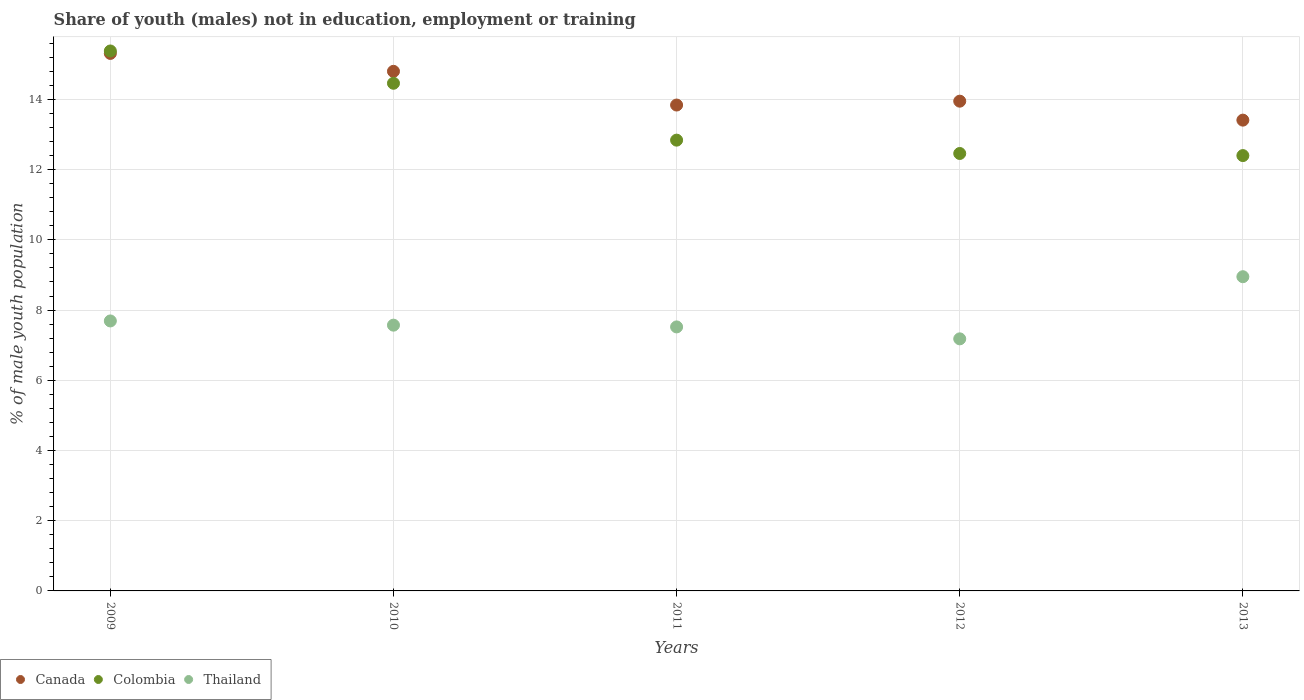What is the percentage of unemployed males population in in Colombia in 2012?
Provide a succinct answer. 12.46. Across all years, what is the maximum percentage of unemployed males population in in Canada?
Offer a very short reply. 15.31. Across all years, what is the minimum percentage of unemployed males population in in Colombia?
Keep it short and to the point. 12.4. In which year was the percentage of unemployed males population in in Canada minimum?
Your answer should be very brief. 2013. What is the total percentage of unemployed males population in in Canada in the graph?
Provide a short and direct response. 71.31. What is the difference between the percentage of unemployed males population in in Colombia in 2009 and that in 2012?
Make the answer very short. 2.92. What is the difference between the percentage of unemployed males population in in Colombia in 2010 and the percentage of unemployed males population in in Thailand in 2012?
Make the answer very short. 7.28. What is the average percentage of unemployed males population in in Canada per year?
Provide a short and direct response. 14.26. In the year 2011, what is the difference between the percentage of unemployed males population in in Thailand and percentage of unemployed males population in in Colombia?
Make the answer very short. -5.32. In how many years, is the percentage of unemployed males population in in Colombia greater than 12.8 %?
Offer a terse response. 3. What is the ratio of the percentage of unemployed males population in in Thailand in 2010 to that in 2011?
Give a very brief answer. 1.01. Is the difference between the percentage of unemployed males population in in Thailand in 2009 and 2012 greater than the difference between the percentage of unemployed males population in in Colombia in 2009 and 2012?
Offer a very short reply. No. What is the difference between the highest and the second highest percentage of unemployed males population in in Colombia?
Provide a short and direct response. 0.92. What is the difference between the highest and the lowest percentage of unemployed males population in in Colombia?
Ensure brevity in your answer.  2.98. Is it the case that in every year, the sum of the percentage of unemployed males population in in Canada and percentage of unemployed males population in in Colombia  is greater than the percentage of unemployed males population in in Thailand?
Your answer should be compact. Yes. Does the percentage of unemployed males population in in Colombia monotonically increase over the years?
Ensure brevity in your answer.  No. Is the percentage of unemployed males population in in Colombia strictly greater than the percentage of unemployed males population in in Thailand over the years?
Provide a short and direct response. Yes. Is the percentage of unemployed males population in in Canada strictly less than the percentage of unemployed males population in in Thailand over the years?
Keep it short and to the point. No. How many dotlines are there?
Your answer should be very brief. 3. How many years are there in the graph?
Your response must be concise. 5. What is the title of the graph?
Your answer should be very brief. Share of youth (males) not in education, employment or training. Does "Zimbabwe" appear as one of the legend labels in the graph?
Keep it short and to the point. No. What is the label or title of the Y-axis?
Ensure brevity in your answer.  % of male youth population. What is the % of male youth population in Canada in 2009?
Provide a short and direct response. 15.31. What is the % of male youth population of Colombia in 2009?
Provide a succinct answer. 15.38. What is the % of male youth population of Thailand in 2009?
Provide a short and direct response. 7.69. What is the % of male youth population in Canada in 2010?
Your response must be concise. 14.8. What is the % of male youth population of Colombia in 2010?
Offer a terse response. 14.46. What is the % of male youth population of Thailand in 2010?
Offer a very short reply. 7.57. What is the % of male youth population of Canada in 2011?
Provide a short and direct response. 13.84. What is the % of male youth population in Colombia in 2011?
Offer a terse response. 12.84. What is the % of male youth population of Thailand in 2011?
Provide a succinct answer. 7.52. What is the % of male youth population in Canada in 2012?
Make the answer very short. 13.95. What is the % of male youth population of Colombia in 2012?
Ensure brevity in your answer.  12.46. What is the % of male youth population of Thailand in 2012?
Make the answer very short. 7.18. What is the % of male youth population in Canada in 2013?
Give a very brief answer. 13.41. What is the % of male youth population in Colombia in 2013?
Offer a very short reply. 12.4. What is the % of male youth population in Thailand in 2013?
Make the answer very short. 8.95. Across all years, what is the maximum % of male youth population in Canada?
Provide a succinct answer. 15.31. Across all years, what is the maximum % of male youth population in Colombia?
Provide a short and direct response. 15.38. Across all years, what is the maximum % of male youth population of Thailand?
Your answer should be compact. 8.95. Across all years, what is the minimum % of male youth population in Canada?
Provide a short and direct response. 13.41. Across all years, what is the minimum % of male youth population in Colombia?
Your answer should be very brief. 12.4. Across all years, what is the minimum % of male youth population in Thailand?
Your answer should be compact. 7.18. What is the total % of male youth population of Canada in the graph?
Make the answer very short. 71.31. What is the total % of male youth population of Colombia in the graph?
Your answer should be very brief. 67.54. What is the total % of male youth population in Thailand in the graph?
Your response must be concise. 38.91. What is the difference between the % of male youth population in Canada in 2009 and that in 2010?
Your answer should be very brief. 0.51. What is the difference between the % of male youth population of Thailand in 2009 and that in 2010?
Provide a succinct answer. 0.12. What is the difference between the % of male youth population in Canada in 2009 and that in 2011?
Offer a terse response. 1.47. What is the difference between the % of male youth population of Colombia in 2009 and that in 2011?
Your answer should be very brief. 2.54. What is the difference between the % of male youth population in Thailand in 2009 and that in 2011?
Offer a very short reply. 0.17. What is the difference between the % of male youth population in Canada in 2009 and that in 2012?
Provide a short and direct response. 1.36. What is the difference between the % of male youth population of Colombia in 2009 and that in 2012?
Offer a terse response. 2.92. What is the difference between the % of male youth population in Thailand in 2009 and that in 2012?
Ensure brevity in your answer.  0.51. What is the difference between the % of male youth population in Canada in 2009 and that in 2013?
Your answer should be very brief. 1.9. What is the difference between the % of male youth population in Colombia in 2009 and that in 2013?
Your answer should be very brief. 2.98. What is the difference between the % of male youth population in Thailand in 2009 and that in 2013?
Offer a terse response. -1.26. What is the difference between the % of male youth population in Colombia in 2010 and that in 2011?
Provide a succinct answer. 1.62. What is the difference between the % of male youth population in Canada in 2010 and that in 2012?
Offer a terse response. 0.85. What is the difference between the % of male youth population of Colombia in 2010 and that in 2012?
Ensure brevity in your answer.  2. What is the difference between the % of male youth population in Thailand in 2010 and that in 2012?
Ensure brevity in your answer.  0.39. What is the difference between the % of male youth population in Canada in 2010 and that in 2013?
Ensure brevity in your answer.  1.39. What is the difference between the % of male youth population in Colombia in 2010 and that in 2013?
Give a very brief answer. 2.06. What is the difference between the % of male youth population in Thailand in 2010 and that in 2013?
Keep it short and to the point. -1.38. What is the difference between the % of male youth population of Canada in 2011 and that in 2012?
Ensure brevity in your answer.  -0.11. What is the difference between the % of male youth population in Colombia in 2011 and that in 2012?
Provide a short and direct response. 0.38. What is the difference between the % of male youth population in Thailand in 2011 and that in 2012?
Provide a succinct answer. 0.34. What is the difference between the % of male youth population in Canada in 2011 and that in 2013?
Keep it short and to the point. 0.43. What is the difference between the % of male youth population in Colombia in 2011 and that in 2013?
Give a very brief answer. 0.44. What is the difference between the % of male youth population of Thailand in 2011 and that in 2013?
Give a very brief answer. -1.43. What is the difference between the % of male youth population in Canada in 2012 and that in 2013?
Keep it short and to the point. 0.54. What is the difference between the % of male youth population in Thailand in 2012 and that in 2013?
Your answer should be very brief. -1.77. What is the difference between the % of male youth population in Canada in 2009 and the % of male youth population in Colombia in 2010?
Give a very brief answer. 0.85. What is the difference between the % of male youth population of Canada in 2009 and the % of male youth population of Thailand in 2010?
Make the answer very short. 7.74. What is the difference between the % of male youth population of Colombia in 2009 and the % of male youth population of Thailand in 2010?
Offer a very short reply. 7.81. What is the difference between the % of male youth population in Canada in 2009 and the % of male youth population in Colombia in 2011?
Make the answer very short. 2.47. What is the difference between the % of male youth population of Canada in 2009 and the % of male youth population of Thailand in 2011?
Make the answer very short. 7.79. What is the difference between the % of male youth population of Colombia in 2009 and the % of male youth population of Thailand in 2011?
Offer a very short reply. 7.86. What is the difference between the % of male youth population in Canada in 2009 and the % of male youth population in Colombia in 2012?
Offer a terse response. 2.85. What is the difference between the % of male youth population of Canada in 2009 and the % of male youth population of Thailand in 2012?
Keep it short and to the point. 8.13. What is the difference between the % of male youth population of Canada in 2009 and the % of male youth population of Colombia in 2013?
Your answer should be compact. 2.91. What is the difference between the % of male youth population of Canada in 2009 and the % of male youth population of Thailand in 2013?
Provide a succinct answer. 6.36. What is the difference between the % of male youth population of Colombia in 2009 and the % of male youth population of Thailand in 2013?
Make the answer very short. 6.43. What is the difference between the % of male youth population of Canada in 2010 and the % of male youth population of Colombia in 2011?
Your answer should be very brief. 1.96. What is the difference between the % of male youth population in Canada in 2010 and the % of male youth population in Thailand in 2011?
Your response must be concise. 7.28. What is the difference between the % of male youth population in Colombia in 2010 and the % of male youth population in Thailand in 2011?
Your answer should be compact. 6.94. What is the difference between the % of male youth population in Canada in 2010 and the % of male youth population in Colombia in 2012?
Your answer should be very brief. 2.34. What is the difference between the % of male youth population of Canada in 2010 and the % of male youth population of Thailand in 2012?
Provide a succinct answer. 7.62. What is the difference between the % of male youth population in Colombia in 2010 and the % of male youth population in Thailand in 2012?
Give a very brief answer. 7.28. What is the difference between the % of male youth population in Canada in 2010 and the % of male youth population in Colombia in 2013?
Your answer should be very brief. 2.4. What is the difference between the % of male youth population in Canada in 2010 and the % of male youth population in Thailand in 2013?
Provide a short and direct response. 5.85. What is the difference between the % of male youth population in Colombia in 2010 and the % of male youth population in Thailand in 2013?
Provide a short and direct response. 5.51. What is the difference between the % of male youth population in Canada in 2011 and the % of male youth population in Colombia in 2012?
Give a very brief answer. 1.38. What is the difference between the % of male youth population of Canada in 2011 and the % of male youth population of Thailand in 2012?
Ensure brevity in your answer.  6.66. What is the difference between the % of male youth population of Colombia in 2011 and the % of male youth population of Thailand in 2012?
Provide a short and direct response. 5.66. What is the difference between the % of male youth population of Canada in 2011 and the % of male youth population of Colombia in 2013?
Your response must be concise. 1.44. What is the difference between the % of male youth population of Canada in 2011 and the % of male youth population of Thailand in 2013?
Make the answer very short. 4.89. What is the difference between the % of male youth population of Colombia in 2011 and the % of male youth population of Thailand in 2013?
Offer a very short reply. 3.89. What is the difference between the % of male youth population in Canada in 2012 and the % of male youth population in Colombia in 2013?
Provide a succinct answer. 1.55. What is the difference between the % of male youth population in Canada in 2012 and the % of male youth population in Thailand in 2013?
Provide a succinct answer. 5. What is the difference between the % of male youth population in Colombia in 2012 and the % of male youth population in Thailand in 2013?
Your answer should be very brief. 3.51. What is the average % of male youth population of Canada per year?
Provide a short and direct response. 14.26. What is the average % of male youth population in Colombia per year?
Your answer should be compact. 13.51. What is the average % of male youth population in Thailand per year?
Your answer should be compact. 7.78. In the year 2009, what is the difference between the % of male youth population of Canada and % of male youth population of Colombia?
Offer a very short reply. -0.07. In the year 2009, what is the difference between the % of male youth population of Canada and % of male youth population of Thailand?
Provide a succinct answer. 7.62. In the year 2009, what is the difference between the % of male youth population of Colombia and % of male youth population of Thailand?
Make the answer very short. 7.69. In the year 2010, what is the difference between the % of male youth population of Canada and % of male youth population of Colombia?
Offer a terse response. 0.34. In the year 2010, what is the difference between the % of male youth population of Canada and % of male youth population of Thailand?
Your answer should be very brief. 7.23. In the year 2010, what is the difference between the % of male youth population of Colombia and % of male youth population of Thailand?
Your response must be concise. 6.89. In the year 2011, what is the difference between the % of male youth population of Canada and % of male youth population of Colombia?
Keep it short and to the point. 1. In the year 2011, what is the difference between the % of male youth population in Canada and % of male youth population in Thailand?
Your answer should be compact. 6.32. In the year 2011, what is the difference between the % of male youth population in Colombia and % of male youth population in Thailand?
Ensure brevity in your answer.  5.32. In the year 2012, what is the difference between the % of male youth population of Canada and % of male youth population of Colombia?
Your answer should be very brief. 1.49. In the year 2012, what is the difference between the % of male youth population in Canada and % of male youth population in Thailand?
Provide a short and direct response. 6.77. In the year 2012, what is the difference between the % of male youth population of Colombia and % of male youth population of Thailand?
Ensure brevity in your answer.  5.28. In the year 2013, what is the difference between the % of male youth population in Canada and % of male youth population in Colombia?
Provide a succinct answer. 1.01. In the year 2013, what is the difference between the % of male youth population of Canada and % of male youth population of Thailand?
Ensure brevity in your answer.  4.46. In the year 2013, what is the difference between the % of male youth population of Colombia and % of male youth population of Thailand?
Provide a succinct answer. 3.45. What is the ratio of the % of male youth population of Canada in 2009 to that in 2010?
Give a very brief answer. 1.03. What is the ratio of the % of male youth population in Colombia in 2009 to that in 2010?
Provide a short and direct response. 1.06. What is the ratio of the % of male youth population in Thailand in 2009 to that in 2010?
Provide a succinct answer. 1.02. What is the ratio of the % of male youth population in Canada in 2009 to that in 2011?
Make the answer very short. 1.11. What is the ratio of the % of male youth population in Colombia in 2009 to that in 2011?
Your answer should be very brief. 1.2. What is the ratio of the % of male youth population of Thailand in 2009 to that in 2011?
Ensure brevity in your answer.  1.02. What is the ratio of the % of male youth population of Canada in 2009 to that in 2012?
Provide a short and direct response. 1.1. What is the ratio of the % of male youth population in Colombia in 2009 to that in 2012?
Give a very brief answer. 1.23. What is the ratio of the % of male youth population in Thailand in 2009 to that in 2012?
Ensure brevity in your answer.  1.07. What is the ratio of the % of male youth population in Canada in 2009 to that in 2013?
Your answer should be compact. 1.14. What is the ratio of the % of male youth population of Colombia in 2009 to that in 2013?
Offer a terse response. 1.24. What is the ratio of the % of male youth population in Thailand in 2009 to that in 2013?
Your response must be concise. 0.86. What is the ratio of the % of male youth population of Canada in 2010 to that in 2011?
Your response must be concise. 1.07. What is the ratio of the % of male youth population in Colombia in 2010 to that in 2011?
Keep it short and to the point. 1.13. What is the ratio of the % of male youth population of Thailand in 2010 to that in 2011?
Provide a succinct answer. 1.01. What is the ratio of the % of male youth population of Canada in 2010 to that in 2012?
Provide a short and direct response. 1.06. What is the ratio of the % of male youth population of Colombia in 2010 to that in 2012?
Give a very brief answer. 1.16. What is the ratio of the % of male youth population of Thailand in 2010 to that in 2012?
Provide a short and direct response. 1.05. What is the ratio of the % of male youth population of Canada in 2010 to that in 2013?
Provide a succinct answer. 1.1. What is the ratio of the % of male youth population in Colombia in 2010 to that in 2013?
Your response must be concise. 1.17. What is the ratio of the % of male youth population in Thailand in 2010 to that in 2013?
Your response must be concise. 0.85. What is the ratio of the % of male youth population of Colombia in 2011 to that in 2012?
Offer a very short reply. 1.03. What is the ratio of the % of male youth population in Thailand in 2011 to that in 2012?
Your response must be concise. 1.05. What is the ratio of the % of male youth population of Canada in 2011 to that in 2013?
Provide a short and direct response. 1.03. What is the ratio of the % of male youth population of Colombia in 2011 to that in 2013?
Give a very brief answer. 1.04. What is the ratio of the % of male youth population of Thailand in 2011 to that in 2013?
Keep it short and to the point. 0.84. What is the ratio of the % of male youth population in Canada in 2012 to that in 2013?
Keep it short and to the point. 1.04. What is the ratio of the % of male youth population of Thailand in 2012 to that in 2013?
Make the answer very short. 0.8. What is the difference between the highest and the second highest % of male youth population in Canada?
Give a very brief answer. 0.51. What is the difference between the highest and the second highest % of male youth population of Colombia?
Ensure brevity in your answer.  0.92. What is the difference between the highest and the second highest % of male youth population of Thailand?
Provide a short and direct response. 1.26. What is the difference between the highest and the lowest % of male youth population of Canada?
Your response must be concise. 1.9. What is the difference between the highest and the lowest % of male youth population of Colombia?
Keep it short and to the point. 2.98. What is the difference between the highest and the lowest % of male youth population in Thailand?
Give a very brief answer. 1.77. 